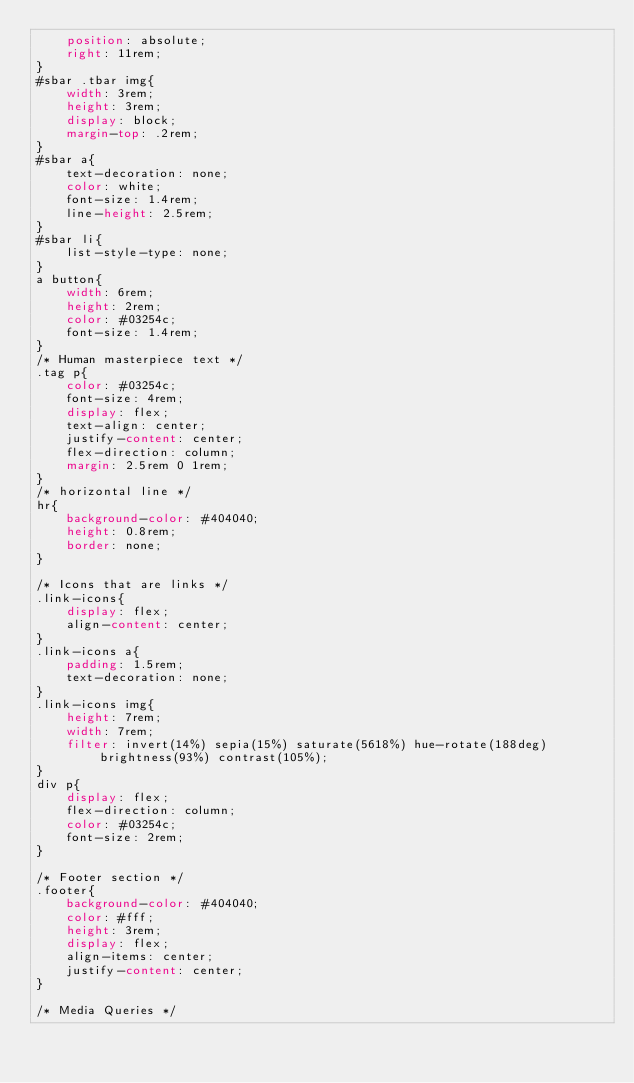<code> <loc_0><loc_0><loc_500><loc_500><_CSS_>    position: absolute;
    right: 11rem;
}
#sbar .tbar img{
    width: 3rem;
    height: 3rem;
    display: block;
    margin-top: .2rem;
}
#sbar a{
    text-decoration: none;
    color: white;
    font-size: 1.4rem;
    line-height: 2.5rem;
}
#sbar li{
    list-style-type: none;
}
a button{
    width: 6rem;
    height: 2rem;
    color: #03254c;
    font-size: 1.4rem;
}
/* Human masterpiece text */
.tag p{
    color: #03254c;
    font-size: 4rem;
    display: flex;
    text-align: center;
    justify-content: center;
    flex-direction: column;
    margin: 2.5rem 0 1rem;
}
/* horizontal line */
hr{
    background-color: #404040;
    height: 0.8rem;
    border: none;
}

/* Icons that are links */
.link-icons{
    display: flex;
    align-content: center;
}
.link-icons a{
    padding: 1.5rem;
    text-decoration: none;
}
.link-icons img{
    height: 7rem;
    width: 7rem;
    filter: invert(14%) sepia(15%) saturate(5618%) hue-rotate(188deg) brightness(93%) contrast(105%);
}
div p{
    display: flex;
    flex-direction: column;
    color: #03254c;
    font-size: 2rem;
}

/* Footer section */
.footer{
    background-color: #404040;
    color: #fff;
    height: 3rem;
    display: flex;
    align-items: center;
    justify-content: center;
}

/* Media Queries */
</code> 